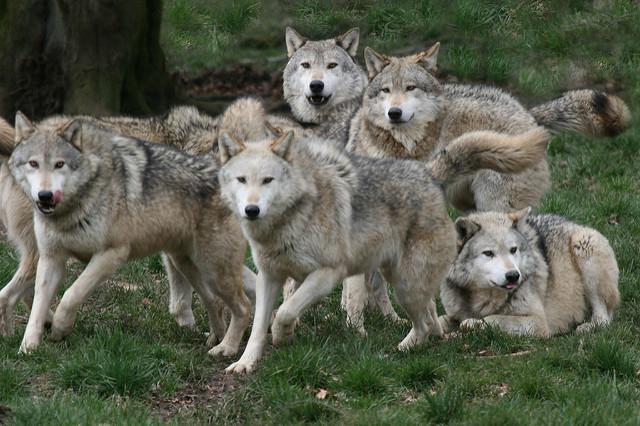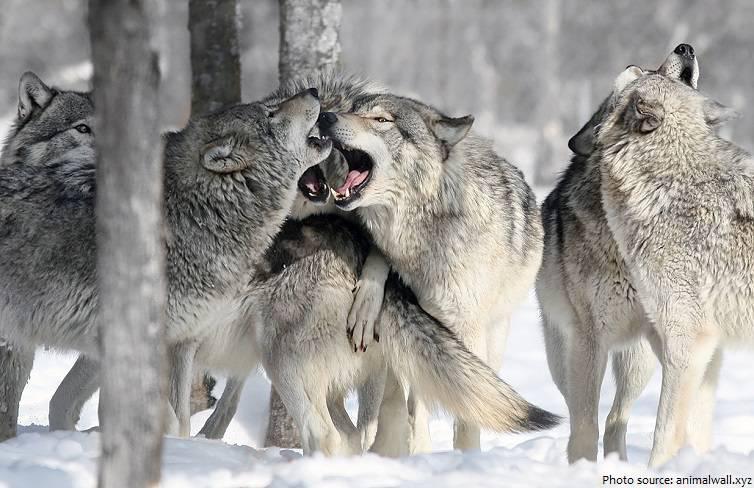The first image is the image on the left, the second image is the image on the right. Evaluate the accuracy of this statement regarding the images: "An image shows a horizontal row of exactly three wolves, and all are in similar poses.". Is it true? Answer yes or no. No. The first image is the image on the left, the second image is the image on the right. Given the left and right images, does the statement "The left image contains exactly three wolves." hold true? Answer yes or no. No. 